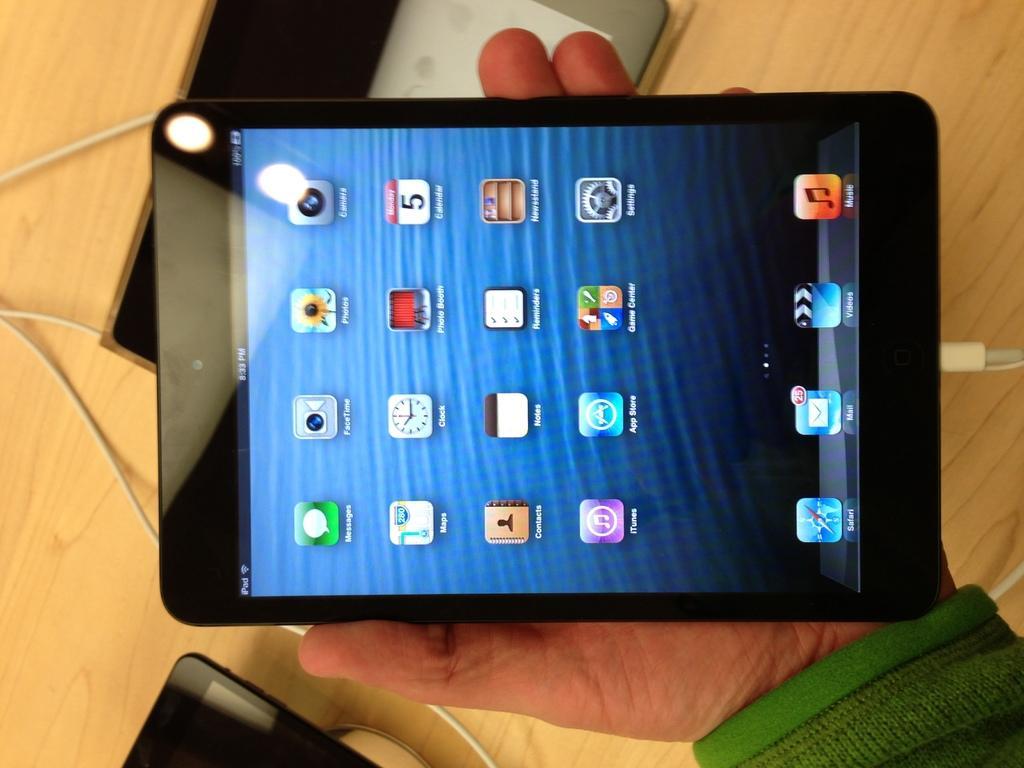Describe this image in one or two sentences. In this image we can see a person's hand holding a tablet. At the bottom there is a table and we can see wires and tablets placed on the table. 